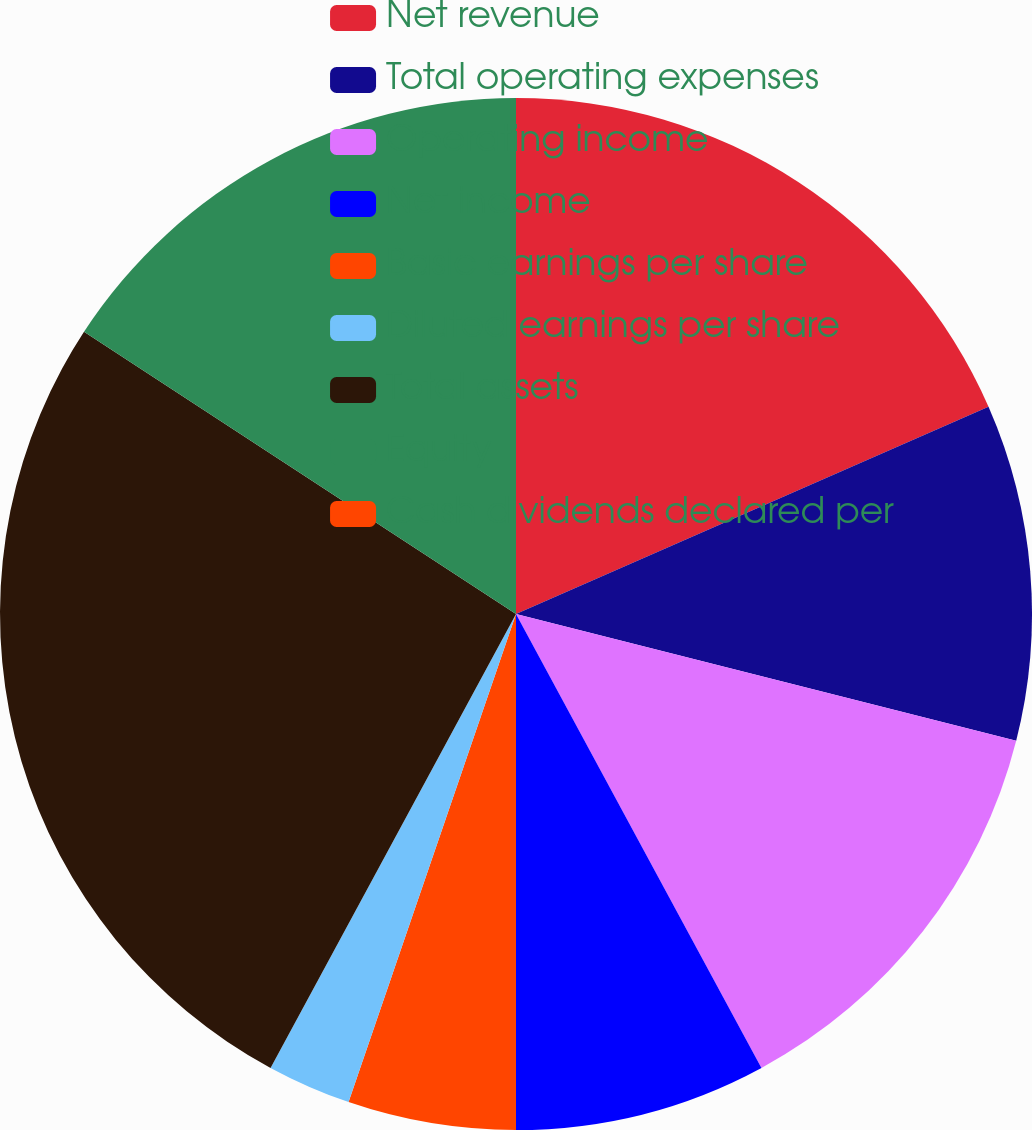Convert chart. <chart><loc_0><loc_0><loc_500><loc_500><pie_chart><fcel>Net revenue<fcel>Total operating expenses<fcel>Operating income<fcel>Net income<fcel>Basic earnings per share<fcel>Diluted earnings per share<fcel>Total assets<fcel>Equity<fcel>Cash dividends declared per<nl><fcel>18.42%<fcel>10.53%<fcel>13.16%<fcel>7.89%<fcel>5.26%<fcel>2.63%<fcel>26.32%<fcel>15.79%<fcel>0.0%<nl></chart> 